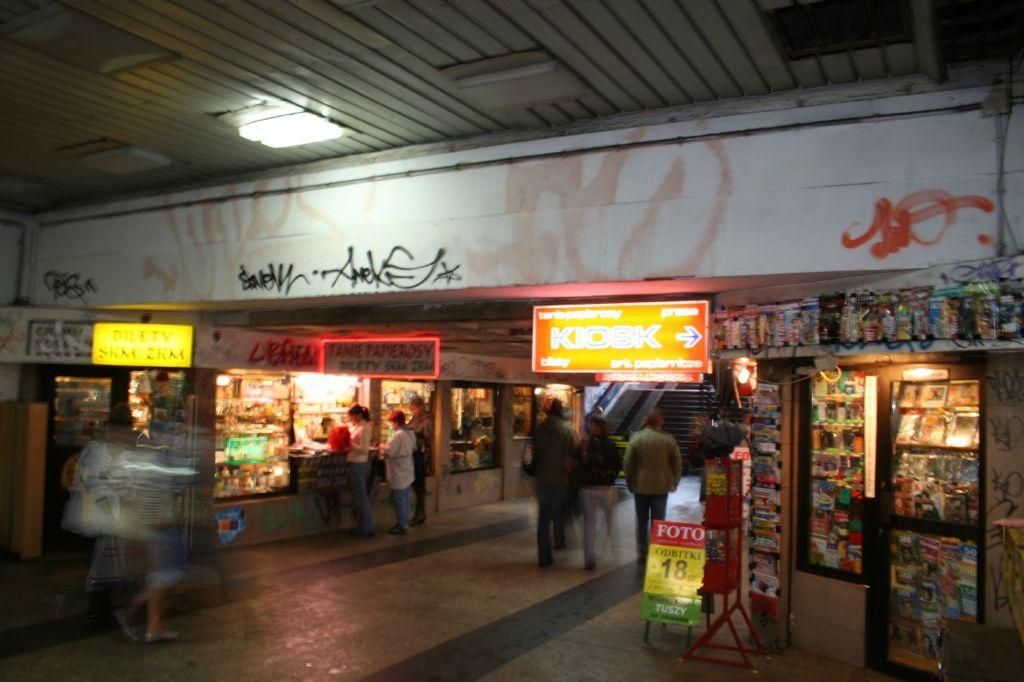<image>
Relay a brief, clear account of the picture shown. A bright orange sign shows the direction to the kiosk. 